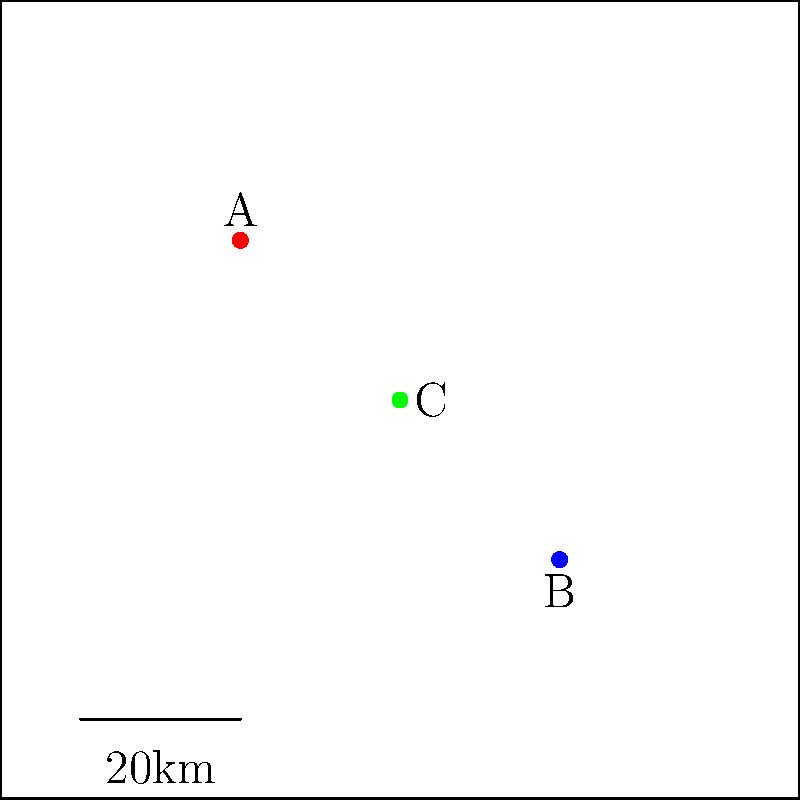In this satellite imagery of Lebanon, three major landmarks are highlighted. Which of these points (A, B, or C) most likely represents the location of Baalbek, the ancient Roman city known for its well-preserved temples? To determine which point likely represents Baalbek, we need to consider its geographical location within Lebanon:

1. Baalbek is located in the Beqaa Valley, in eastern Lebanon.
2. The Beqaa Valley runs from north to south, parallel to Lebanon's coast.
3. Baalbek is situated closer to the Syrian border than to the Mediterranean coast.

Analyzing the map:
- Point A is in the northern part of the country, closer to the coast. This is likely to be Tripoli or a coastal city.
- Point B is in the southern part of the country, which could represent a city like Tyre or Sidon.
- Point C is centrally located but towards the eastern part of the country.

Given Baalbek's location in the eastern part of Lebanon, in the Beqaa Valley, Point C is the most likely candidate among the three options.
Answer: C 